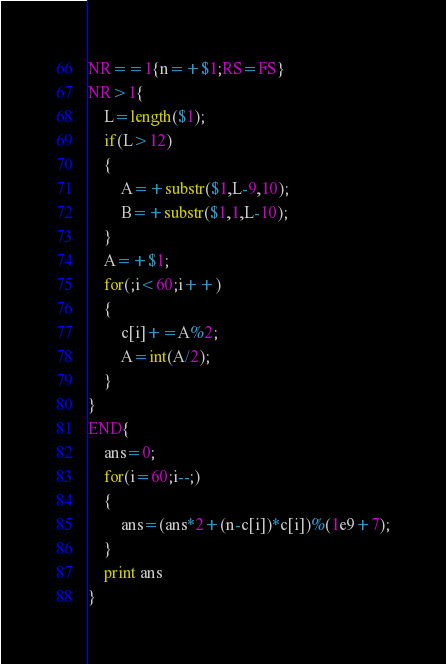<code> <loc_0><loc_0><loc_500><loc_500><_Awk_>NR==1{n=+$1;RS=FS}
NR>1{
	L=length($1);
	if(L>12)
	{
		A=+substr($1,L-9,10);
		B=+substr($1,1,L-10);
	}
	A=+$1;
	for(;i<60;i++)
	{
		c[i]+=A%2;
		A=int(A/2);
	}
}
END{
	ans=0;
	for(i=60;i--;)
	{
		ans=(ans*2+(n-c[i])*c[i])%(1e9+7);
	}
	print ans
}</code> 